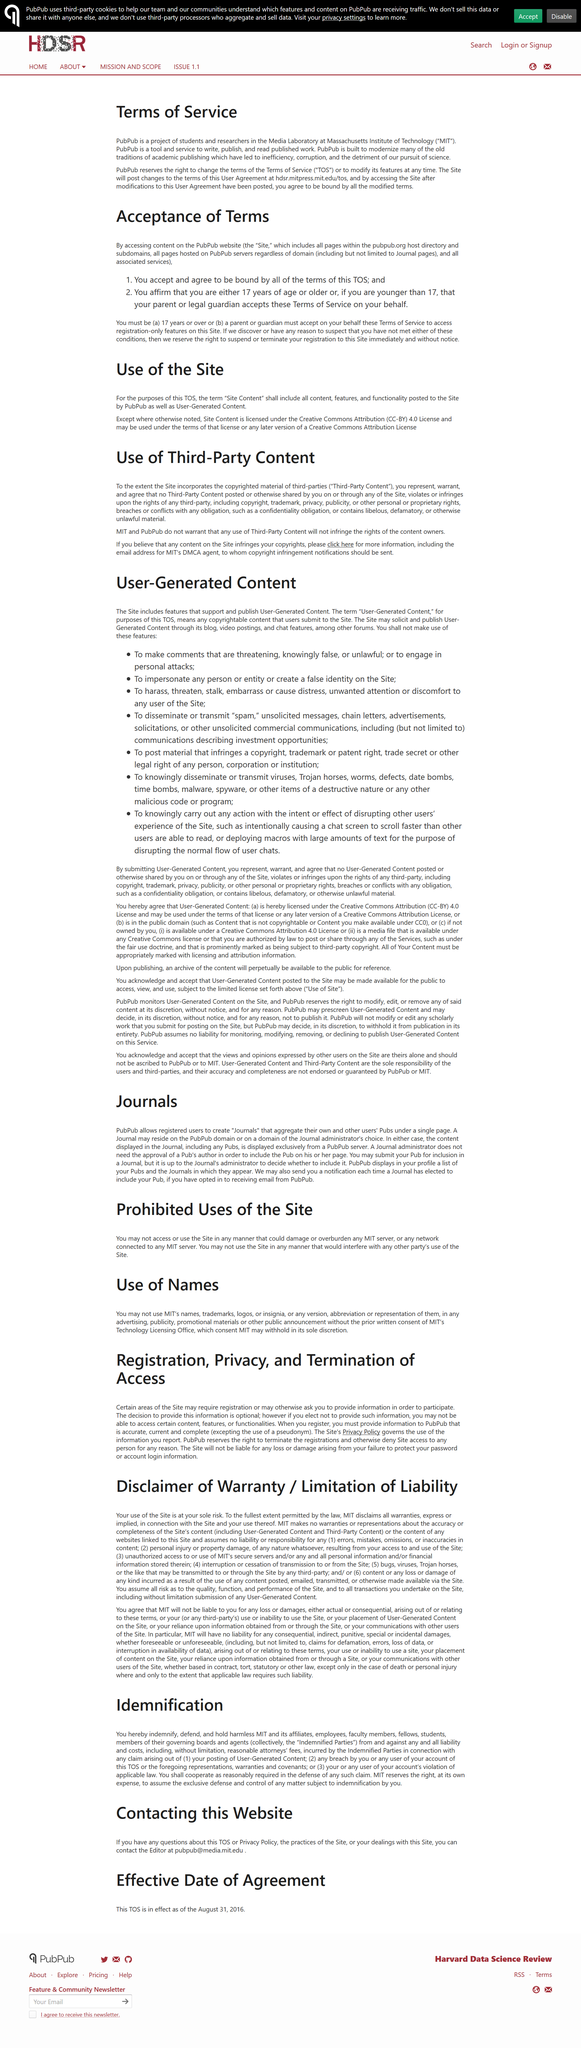Draw attention to some important aspects in this diagram. Terms of Service is an acronym that stands for Terms of Service. The copyright infringement notifications should be sent to the email address for MIT's designated agent. You must be at least 17 years of age to enter this premise. MIT and PubPub do not guarantee that any use of Third-Party Content will not infringe the rights of the content owners. The privacy policy governs the use of the information reported by the site. 